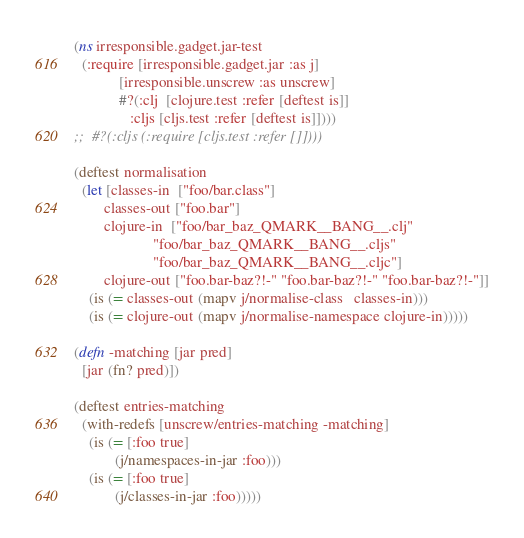Convert code to text. <code><loc_0><loc_0><loc_500><loc_500><_Clojure_>(ns irresponsible.gadget.jar-test
  (:require [irresponsible.gadget.jar :as j]
            [irresponsible.unscrew :as unscrew]
            #?(:clj  [clojure.test :refer [deftest is]]
               :cljs [cljs.test :refer [deftest is]])))
;;  #?(:cljs (:require [cljs.test :refer []])))
  
(deftest normalisation
  (let [classes-in  ["foo/bar.class"]
        classes-out ["foo.bar"]
        clojure-in  ["foo/bar_baz_QMARK__BANG__.clj"
                     "foo/bar_baz_QMARK__BANG__.cljs"
                     "foo/bar_baz_QMARK__BANG__.cljc"]
        clojure-out ["foo.bar-baz?!-" "foo.bar-baz?!-" "foo.bar-baz?!-"]]
    (is (= classes-out (mapv j/normalise-class   classes-in)))
    (is (= clojure-out (mapv j/normalise-namespace clojure-in)))))

(defn -matching [jar pred]
  [jar (fn? pred)])

(deftest entries-matching
  (with-redefs [unscrew/entries-matching -matching]
    (is (= [:foo true]
           (j/namespaces-in-jar :foo)))
    (is (= [:foo true]
           (j/classes-in-jar :foo)))))
</code> 